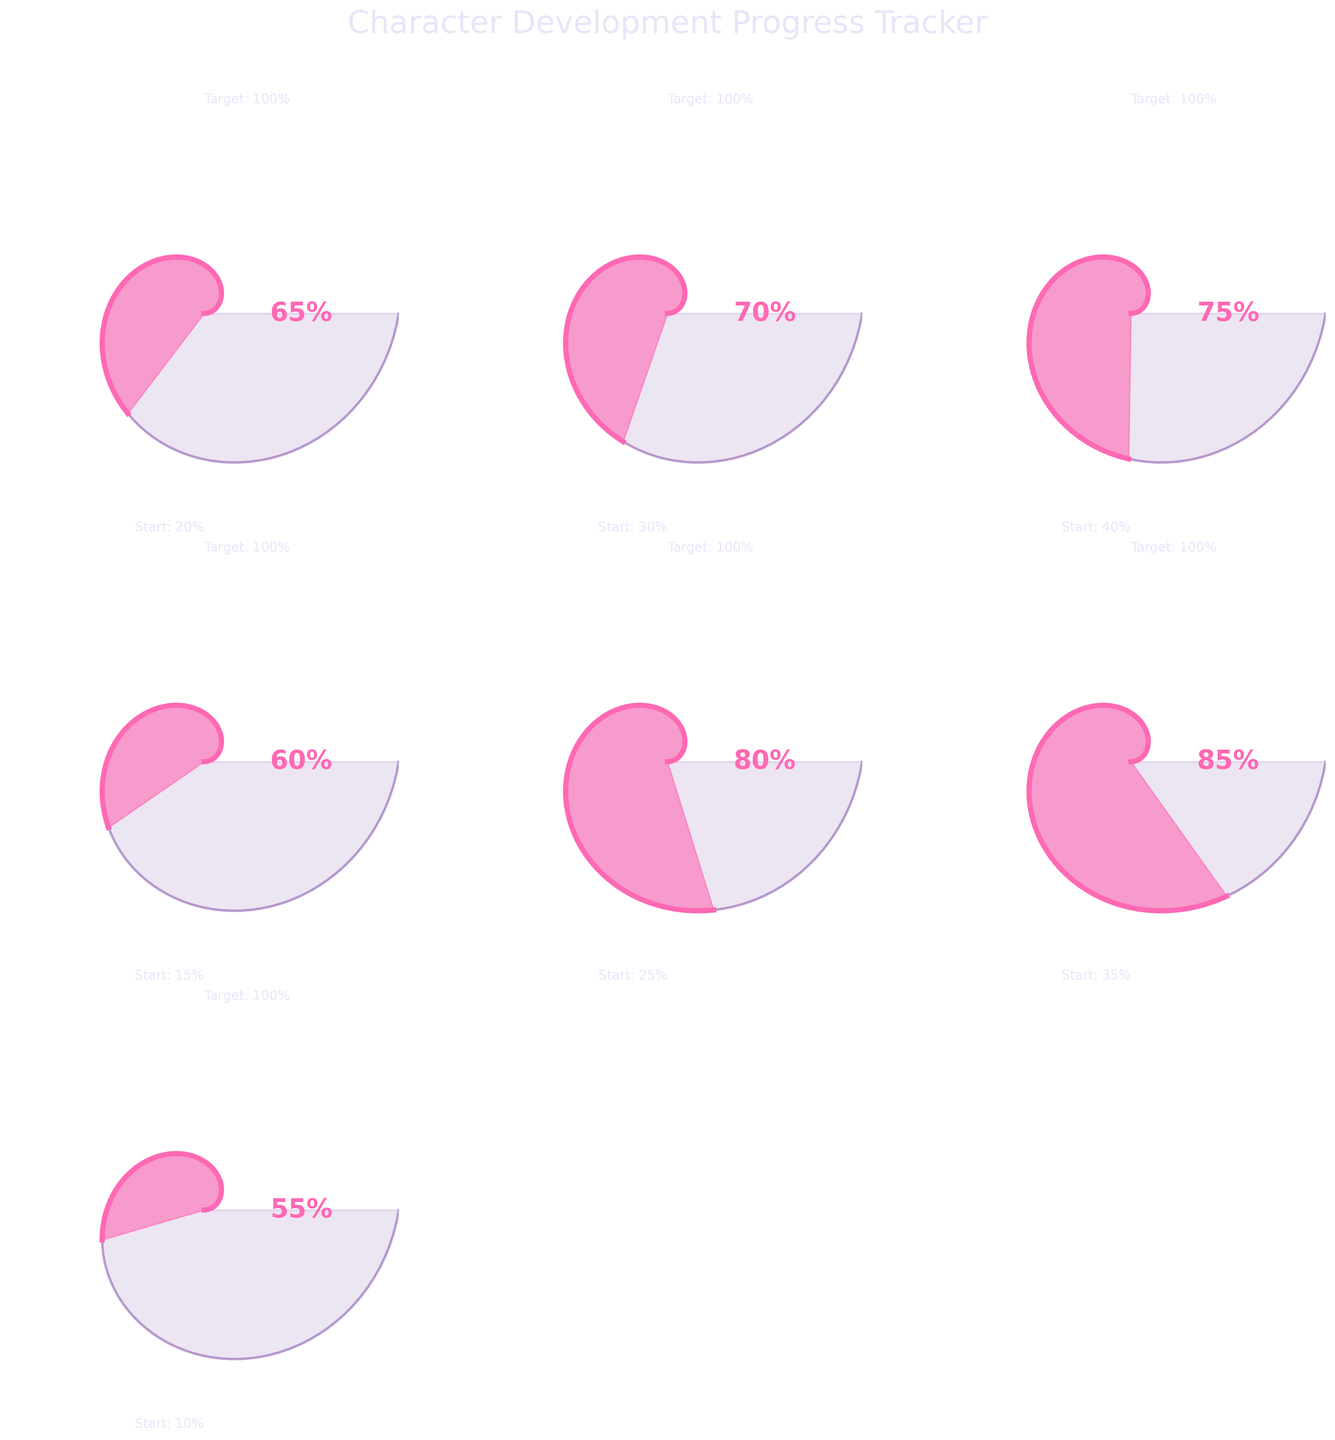What is the title of the figure? The title is often found at the top of the figure, and for this plot, it is "Character Development Progress Tracker".
Answer: Character Development Progress Tracker What trait has the highest current value? By observing each gauge chart, the trait "Dialogue Authenticity" has the highest current value at 85%.
Answer: Dialogue Authenticity How does the current value of "Internal Conflict" compare to the starting value? The starting value of "Internal Conflict" is 10%, and the current value is 55%. So the difference is 55% - 10% = 45%.
Answer: 45% What is the target value for "Complexity"? The target value for "Complexity" can be read directly from the gauge chart of that trait, which is 100%.
Answer: 100% How many traits have a current value greater than 60%? Counting the traits with current values greater than 60%: "Complexity" (70%), "Relatability" (75%), "Backstory Integration" (80%), and "Dialogue Authenticity" (85%).
Answer: 4 Which traits have a starting value lower than 30%? From the starting values, "Emotional Depth" (20%), "Growth Arc" (15%), and "Internal Conflict" (10%) have values below 30%.
Answer: 3 Compare the growth arc of "Emotional Depth" and "Internal Conflict". Which one shows greater development increment? Calculate the increment: "Emotional Depth" increased from 20% to 65%, so 65% - 20% = 45%. "Internal Conflict" increased from 10% to 55%, so 55% - 10% = 45%. Both have the same development increment of 45%.
Answer: Equal What is the average current value of all traits? Calculate the sum of current values: 65% + 70% + 75% + 60% + 80% + 85% + 55% = 490%, then divide by the number of traits, 7. This results in 490 / 7 = 70%.
Answer: 70% Which trait shows the least amount of development from its starting value? The development increment for each: "Emotional Depth" (45%), "Complexity" (40%), "Relatability" (35%), "Growth Arc" (45%), "Backstory Integration" (55%), "Dialogue Authenticity" (50%), "Internal Conflict" (45%). The least increment is "Relatability" at 35%.
Answer: Relatability 